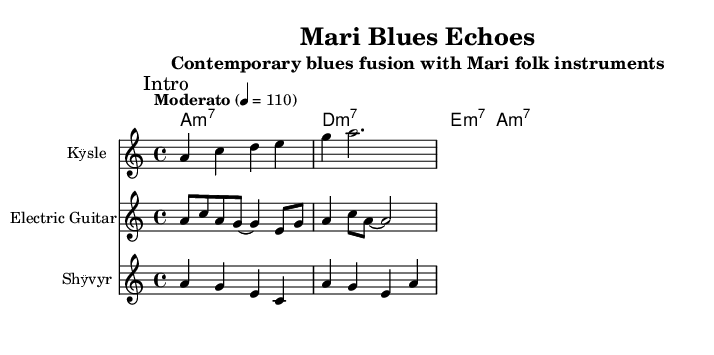What is the key signature of this music? The key signature is A minor, which is indicated by the absence of sharps or flats in the key. A minor is the relative minor of C major.
Answer: A minor What is the time signature of this piece? The time signature is 4/4, which means there are four beats in each measure, and each quarter note gets one beat. This can be seen at the beginning of the score.
Answer: 4/4 What is the tempo marking of the piece? The tempo marking is "Moderato," which designates a moderate speed for the performance of the music. The specific tempo indication is also shown as 4 = 110, indicating the beats per minute.
Answer: Moderato How many measures are present in the introduction section? The introduction section consists of two measures as indicated by the grouping of the notes written for that section.
Answer: 2 What instrument is indicated for the introduction? The introduction section is specified for the instrument "Kӱsle," which is a traditional Mari folk instrument. This is stated in the staff designation.
Answer: Kӱsle How does the chord progression change between sections? The chord progression does not change between the sections; it remains A minor 7, D minor 7, E minor 7, and back to A minor 7 throughout the piece, reflecting typical structures in blues music.
Answer: No change What is the primary form of the musical piece? The structure follows a typical verse-chorus form seen in blues music, with distinct sections for the verse and chorus indicated clearly on the sheet music.
Answer: Verse-Chorus 